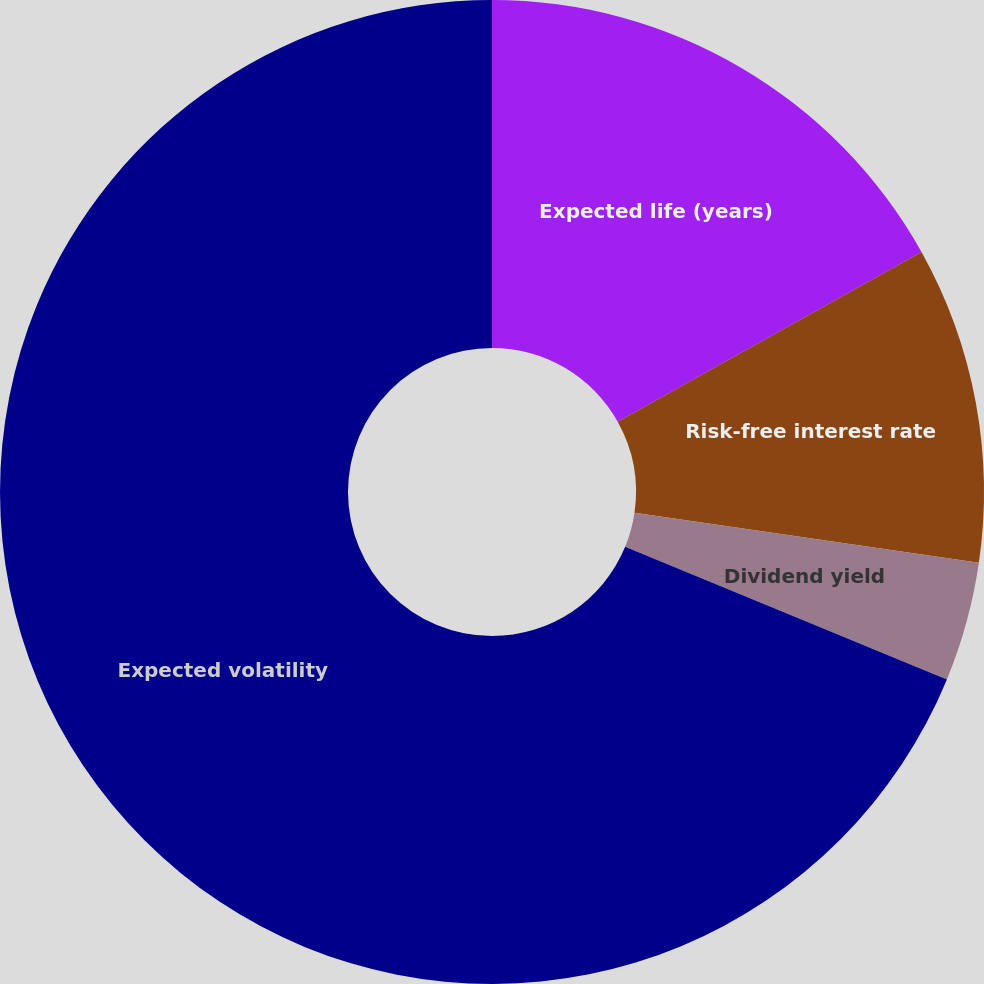Convert chart. <chart><loc_0><loc_0><loc_500><loc_500><pie_chart><fcel>Expected life (years)<fcel>Risk-free interest rate<fcel>Dividend yield<fcel>Expected volatility<nl><fcel>16.89%<fcel>10.41%<fcel>3.92%<fcel>68.78%<nl></chart> 